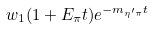Convert formula to latex. <formula><loc_0><loc_0><loc_500><loc_500>w _ { 1 } ( 1 + E _ { \pi } t ) e ^ { - m _ { \eta ^ { \prime } \pi } t }</formula> 